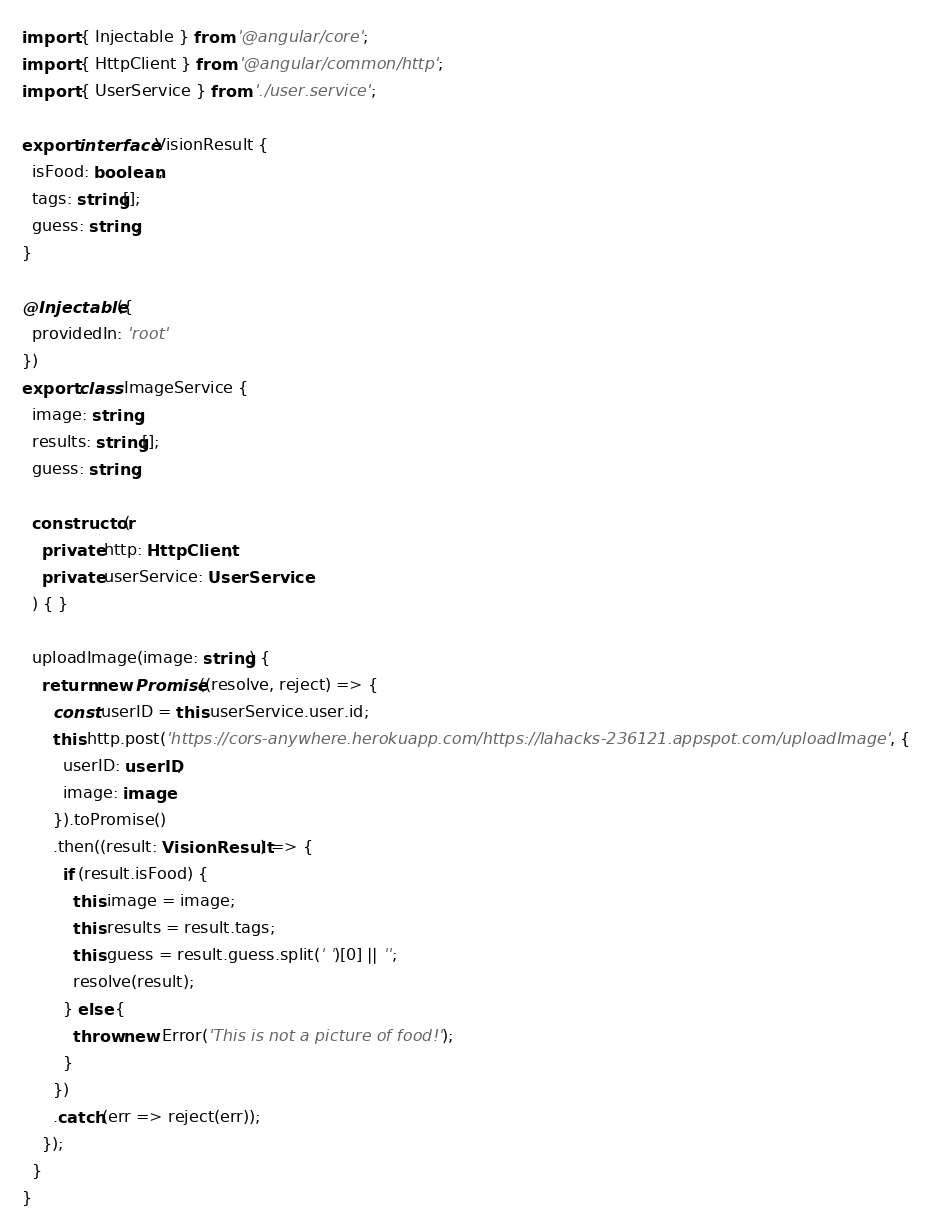Convert code to text. <code><loc_0><loc_0><loc_500><loc_500><_TypeScript_>import { Injectable } from '@angular/core';
import { HttpClient } from '@angular/common/http';
import { UserService } from './user.service';

export interface VisionResult {
  isFood: boolean;
  tags: string[];
  guess: string;
}

@Injectable({
  providedIn: 'root'
})
export class ImageService {
  image: string;
  results: string[];
  guess: string;

  constructor(
    private http: HttpClient,
    private userService: UserService
  ) { }

  uploadImage(image: string) {
    return new Promise((resolve, reject) => {
      const userID = this.userService.user.id;
      this.http.post('https://cors-anywhere.herokuapp.com/https://lahacks-236121.appspot.com/uploadImage', {
        userID: userID,
        image: image
      }).toPromise()
      .then((result: VisionResult) => {
        if (result.isFood) {
          this.image = image;
          this.results = result.tags;
          this.guess = result.guess.split(' ')[0] || '';
          resolve(result);
        } else {
          throw new Error('This is not a picture of food!');
        }
      })
      .catch(err => reject(err));
    });
  }
}
</code> 